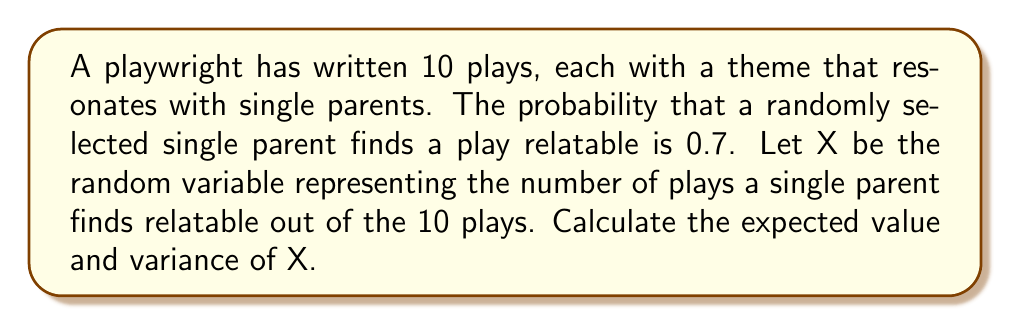Could you help me with this problem? To solve this problem, we need to recognize that this scenario follows a binomial distribution. The number of trials (n) is 10, and the probability of success (p) is 0.7.

Step 1: Calculate the expected value (mean) of X.
For a binomial distribution, the expected value is given by:
$$ E(X) = np $$
Where n is the number of trials and p is the probability of success.

$$ E(X) = 10 \times 0.7 = 7 $$

Step 2: Calculate the variance of X.
For a binomial distribution, the variance is given by:
$$ Var(X) = np(1-p) $$

$$ Var(X) = 10 \times 0.7 \times (1-0.7) $$
$$ Var(X) = 10 \times 0.7 \times 0.3 = 2.1 $$

Therefore, the expected value of X is 7, and the variance of X is 2.1.
Answer: E(X) = 7, Var(X) = 2.1 